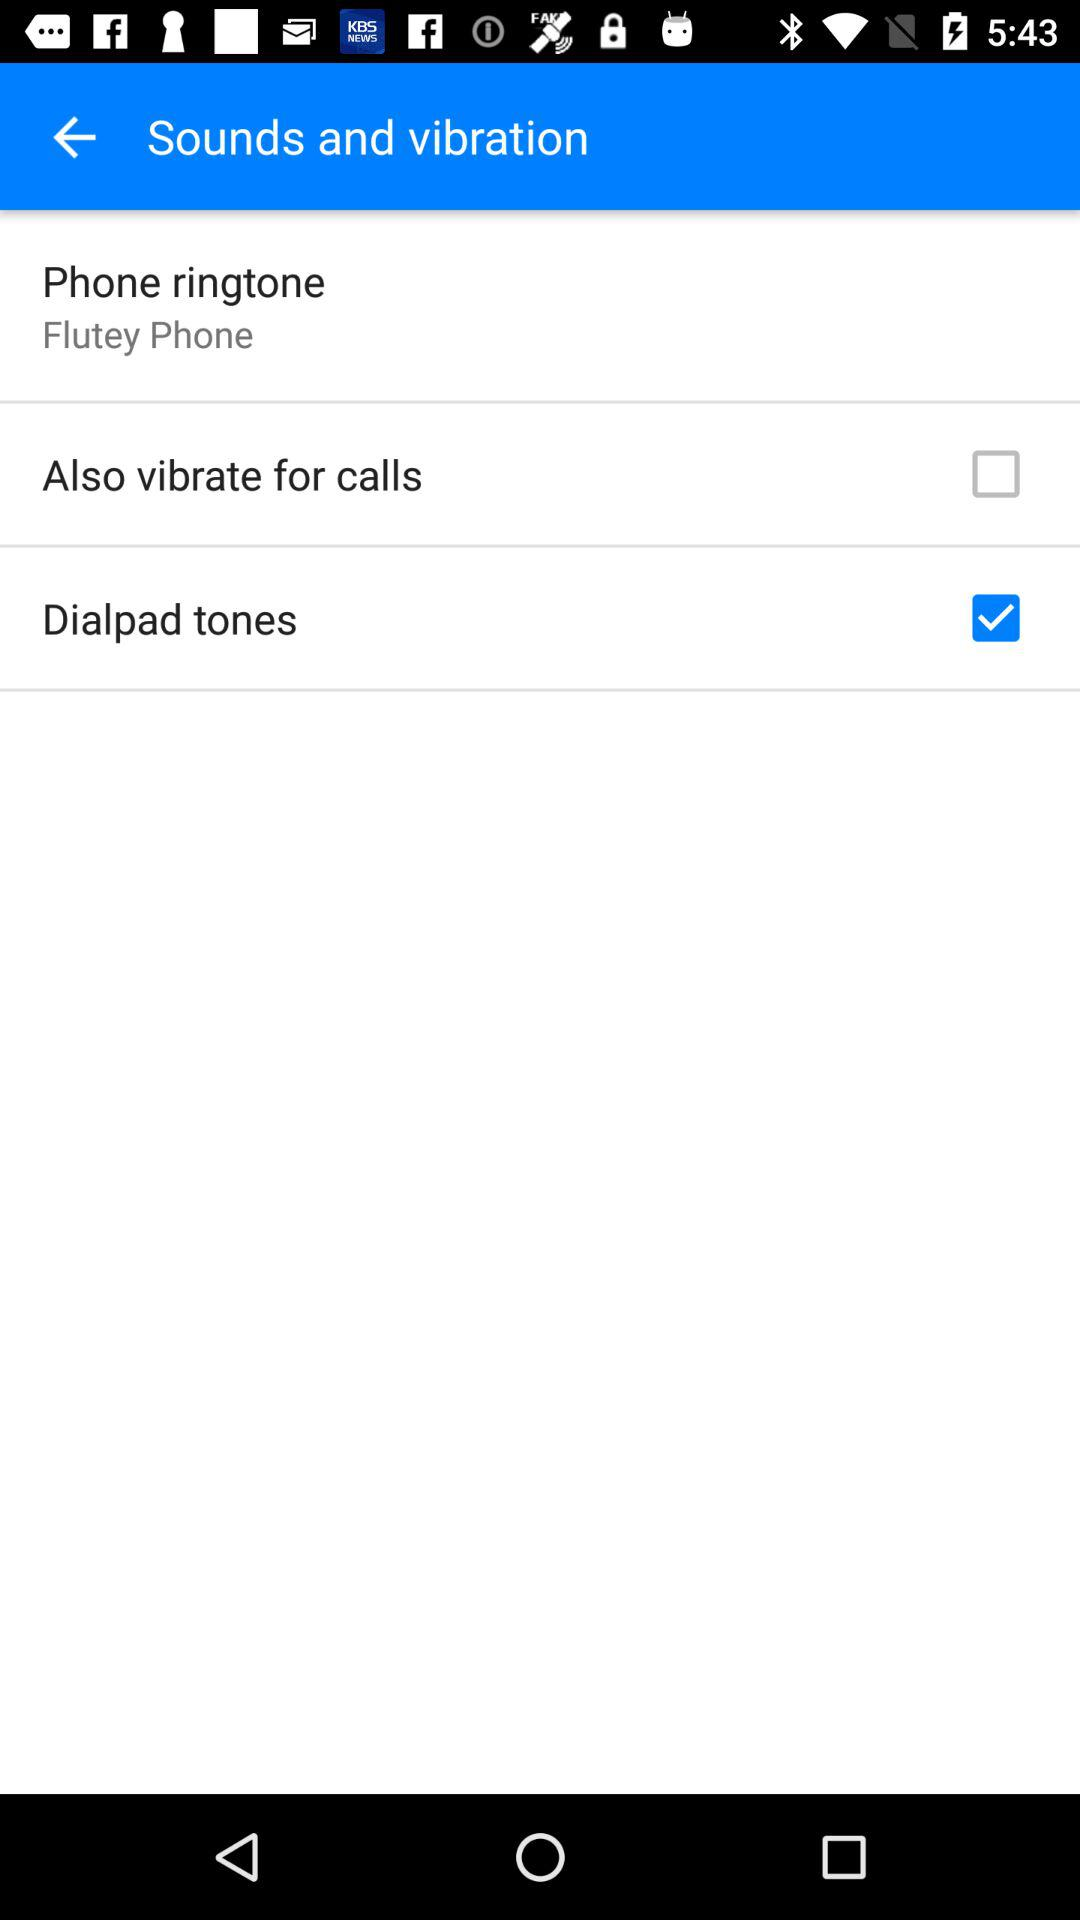How many items have a check box?
Answer the question using a single word or phrase. 2 